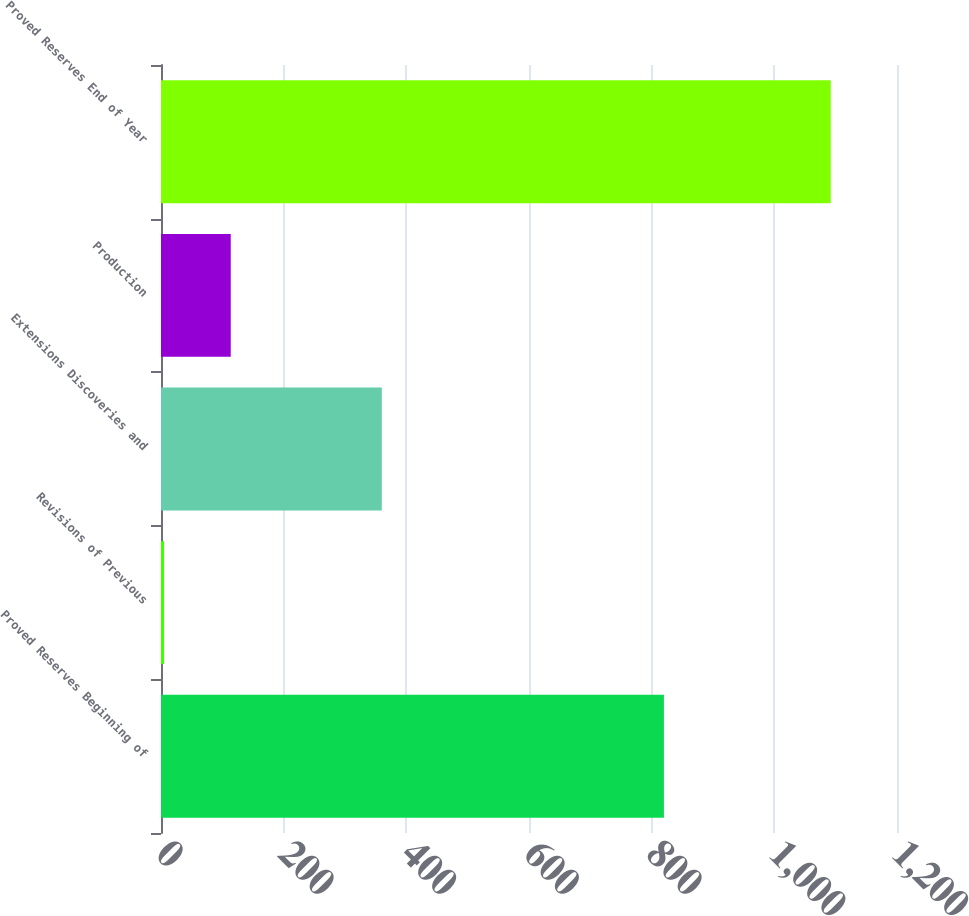<chart> <loc_0><loc_0><loc_500><loc_500><bar_chart><fcel>Proved Reserves Beginning of<fcel>Revisions of Previous<fcel>Extensions Discoveries and<fcel>Production<fcel>Proved Reserves End of Year<nl><fcel>820<fcel>5<fcel>360<fcel>113.7<fcel>1092<nl></chart> 